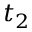Convert formula to latex. <formula><loc_0><loc_0><loc_500><loc_500>t _ { 2 }</formula> 